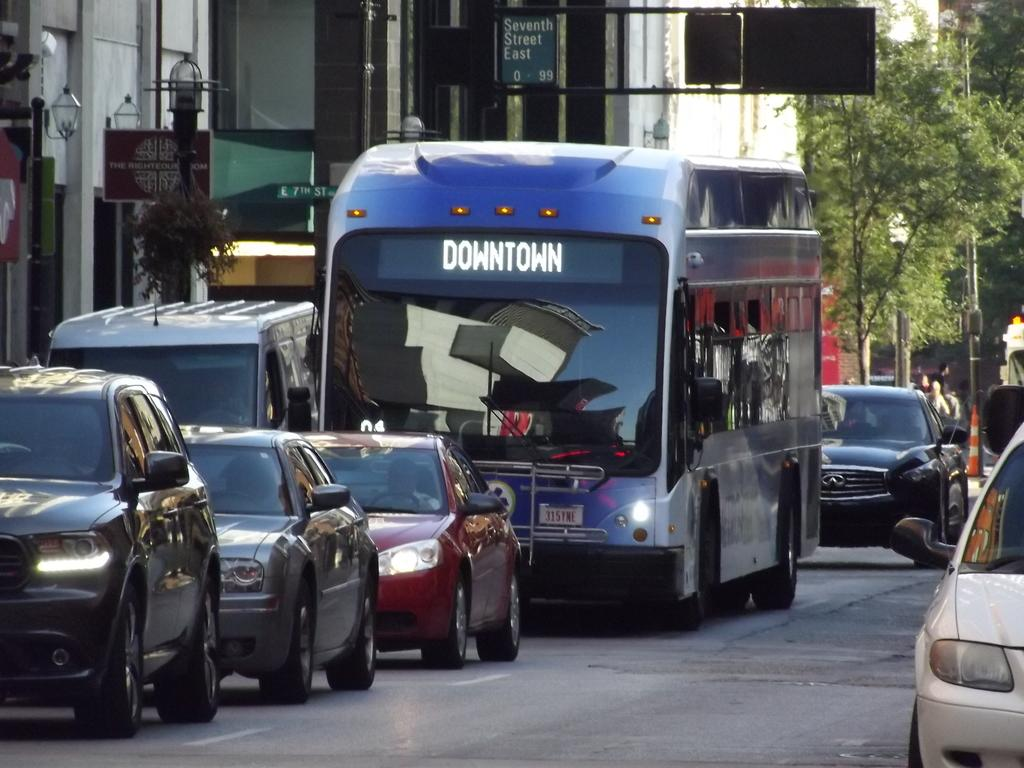What can be seen on the road in the image? There are vehicles on the road in the image. What structures are present to provide illumination at night? There are street lights in the image. What is used to provide directions to people in the image? There is a direction board on a pole in the image. What type of natural scenery is visible in the background of the image? There are trees visible in the background of the image. What type of man-made structures can be seen in the background of the image? There are buildings in the background of the image. Can you tell me what type of guitar is being played in the image? There is no guitar present in the image. What kind of appliance is being used to give someone a haircut in the image? There is no haircut or appliance present in the image. 